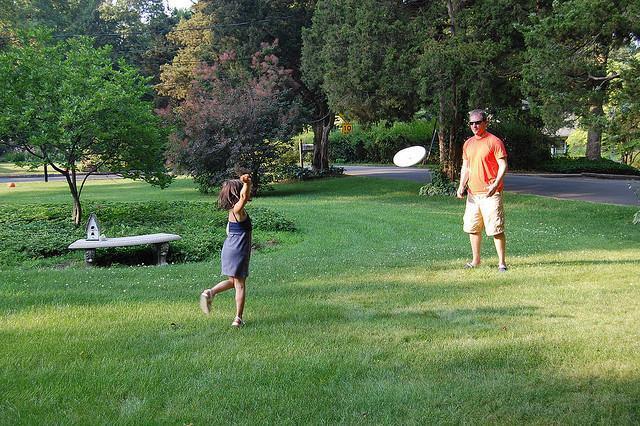How many people are there?
Give a very brief answer. 2. 